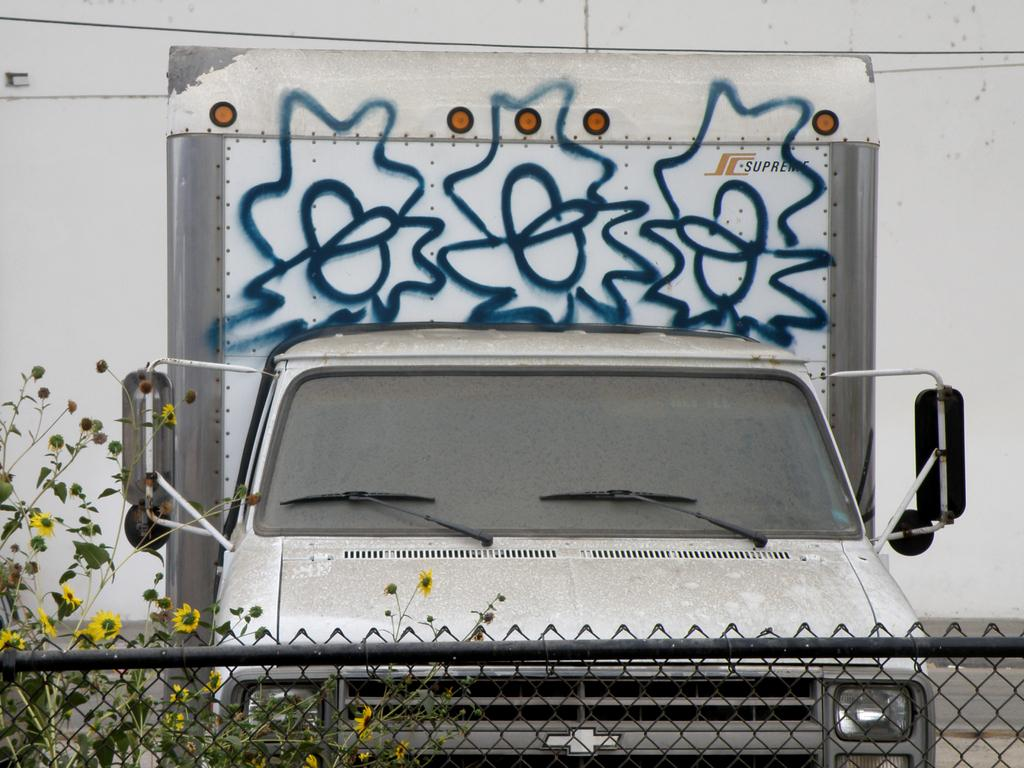What type of vehicle is in the image? There is a truck in the image. What is the truck doing in the image? The truck is parked. What can be seen on the truck? There is painting on the truck. What type of vegetation is present in the image? There are plants with flowers in the image. What type of barrier is visible in the image? There is a metal fence in the image. What type of structure is visible in the image? There is a wall visible in the image. How many visitors are sitting on the duck in the image? There is no duck present in the image, so it is not possible to answer that question. 